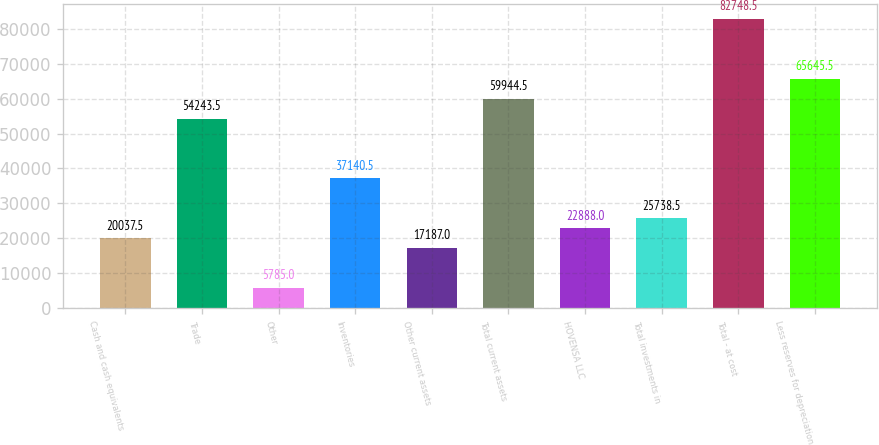<chart> <loc_0><loc_0><loc_500><loc_500><bar_chart><fcel>Cash and cash equivalents<fcel>Trade<fcel>Other<fcel>Inventories<fcel>Other current assets<fcel>Total current assets<fcel>HOVENSA LLC<fcel>Total investments in<fcel>Total - at cost<fcel>Less reserves for depreciation<nl><fcel>20037.5<fcel>54243.5<fcel>5785<fcel>37140.5<fcel>17187<fcel>59944.5<fcel>22888<fcel>25738.5<fcel>82748.5<fcel>65645.5<nl></chart> 